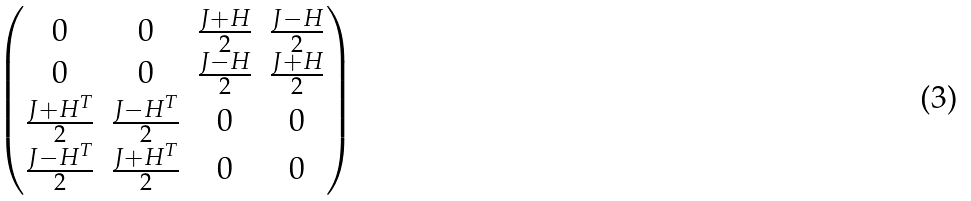Convert formula to latex. <formula><loc_0><loc_0><loc_500><loc_500>\begin{pmatrix} 0 & 0 & \frac { J + H } { 2 } & \frac { J - H } { 2 } \\ 0 & 0 & \frac { J - H } { 2 } & \frac { J + H } { 2 } \\ \frac { J + H ^ { T } } { 2 } & \frac { J - H ^ { T } } { 2 } & 0 & 0 \\ \frac { J - H ^ { T } } { 2 } & \frac { J + H ^ { T } } { 2 } & 0 & 0 \end{pmatrix}</formula> 